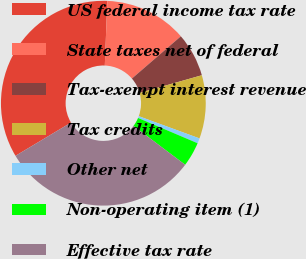<chart> <loc_0><loc_0><loc_500><loc_500><pie_chart><fcel>US federal income tax rate<fcel>State taxes net of federal<fcel>Tax-exempt interest revenue<fcel>Tax credits<fcel>Other net<fcel>Non-operating item (1)<fcel>Effective tax rate<nl><fcel>34.21%<fcel>13.05%<fcel>6.93%<fcel>9.99%<fcel>0.81%<fcel>3.87%<fcel>31.15%<nl></chart> 